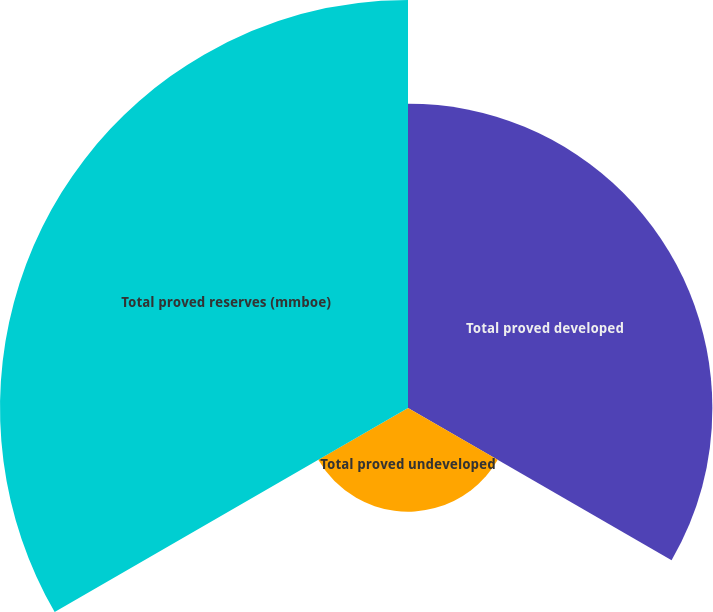Convert chart. <chart><loc_0><loc_0><loc_500><loc_500><pie_chart><fcel>Total proved developed<fcel>Total proved undeveloped<fcel>Total proved reserves (mmboe)<nl><fcel>37.3%<fcel>12.7%<fcel>50.0%<nl></chart> 